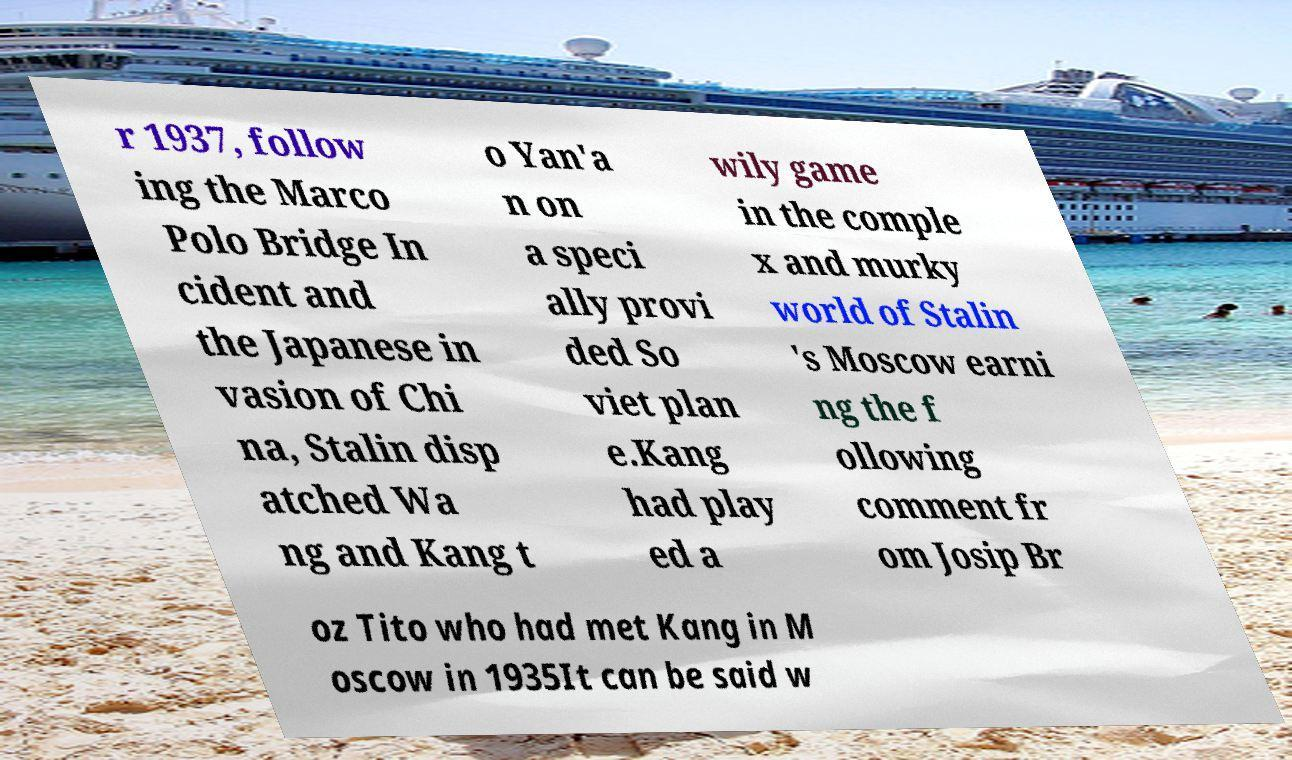What messages or text are displayed in this image? I need them in a readable, typed format. r 1937, follow ing the Marco Polo Bridge In cident and the Japanese in vasion of Chi na, Stalin disp atched Wa ng and Kang t o Yan'a n on a speci ally provi ded So viet plan e.Kang had play ed a wily game in the comple x and murky world of Stalin 's Moscow earni ng the f ollowing comment fr om Josip Br oz Tito who had met Kang in M oscow in 1935It can be said w 